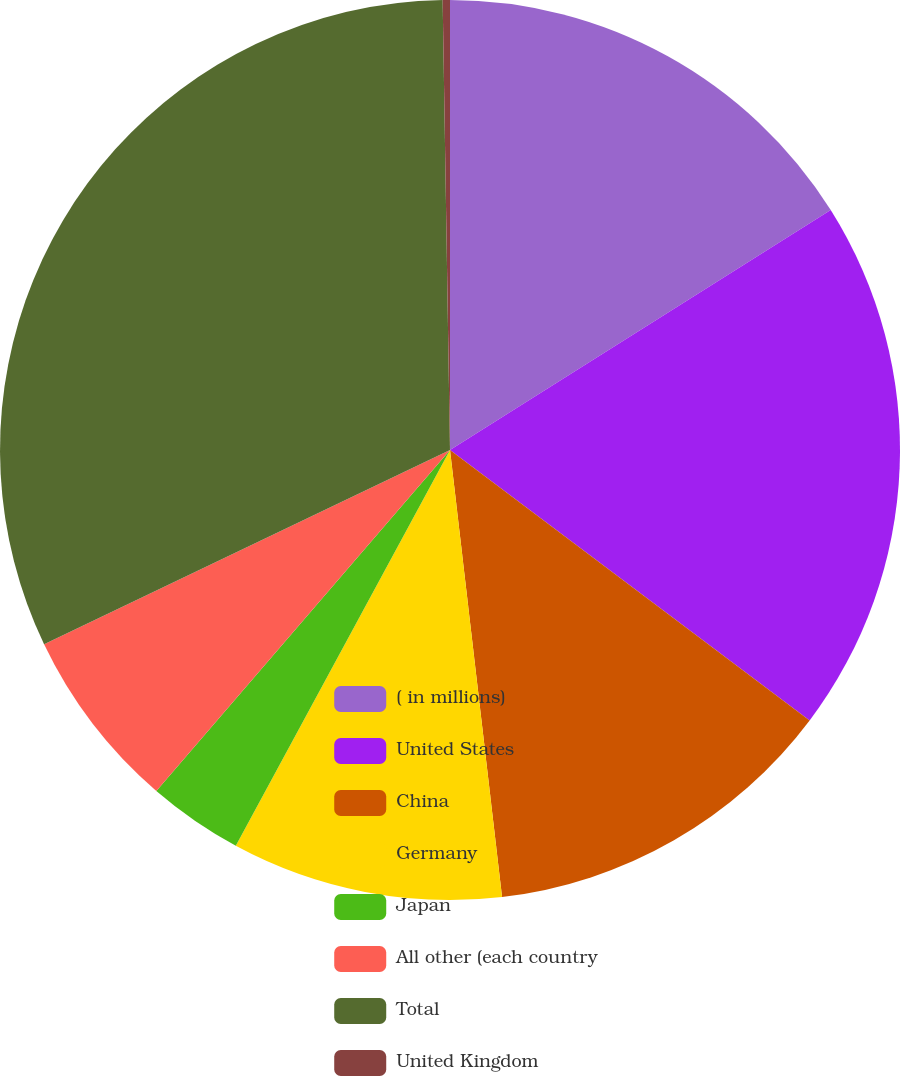Convert chart to OTSL. <chart><loc_0><loc_0><loc_500><loc_500><pie_chart><fcel>( in millions)<fcel>United States<fcel>China<fcel>Germany<fcel>Japan<fcel>All other (each country<fcel>Total<fcel>United Kingdom<nl><fcel>16.05%<fcel>19.21%<fcel>12.89%<fcel>9.74%<fcel>3.42%<fcel>6.58%<fcel>31.84%<fcel>0.26%<nl></chart> 